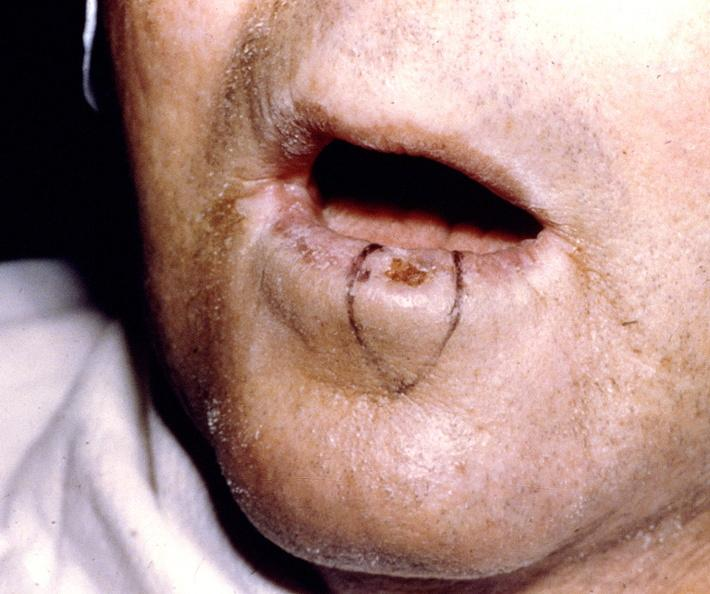what is present?
Answer the question using a single word or phrase. Gastrointestinal 